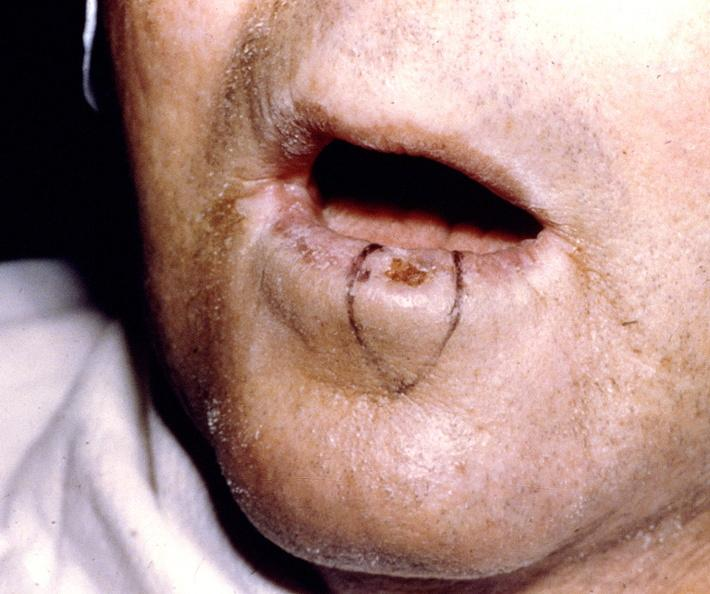what is present?
Answer the question using a single word or phrase. Gastrointestinal 